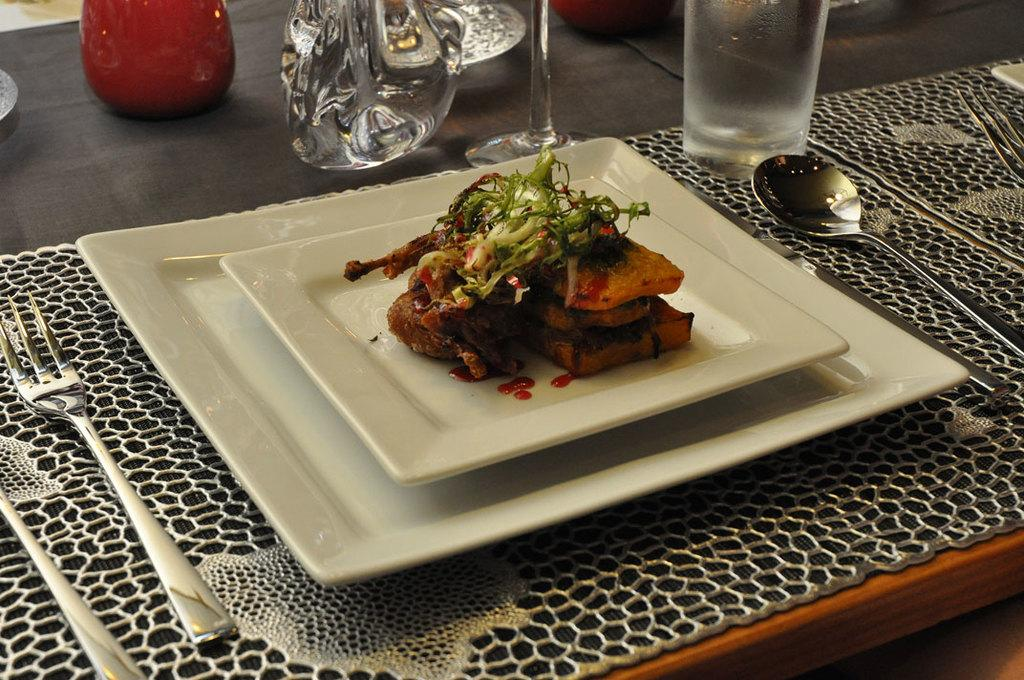What is located at the bottom of the image in the image? There is a table at the bottom of the image. What is placed on the table? There is a plate on the table. What is on the plate? There is food in the plate. What utensils are surrounding the plate? There are spoons, forks, and glasses surrounding the plate. What songs are being sung by the food in the image? There are no songs being sung by the food in the image, as food does not have the ability to sing. 